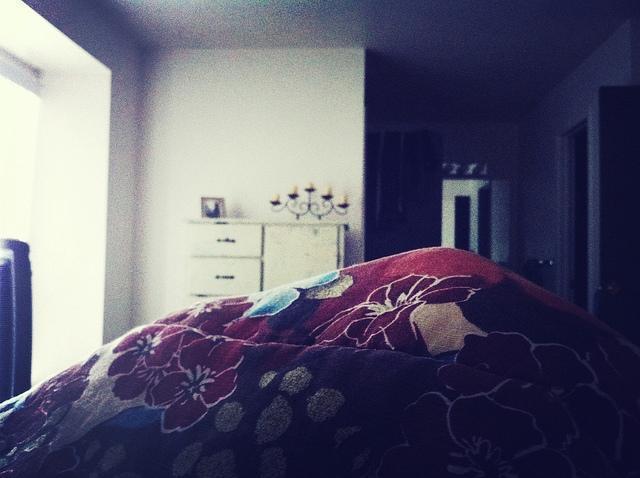How many candles in the background?
Give a very brief answer. 5. How many oranges have stickers on them?
Give a very brief answer. 0. 